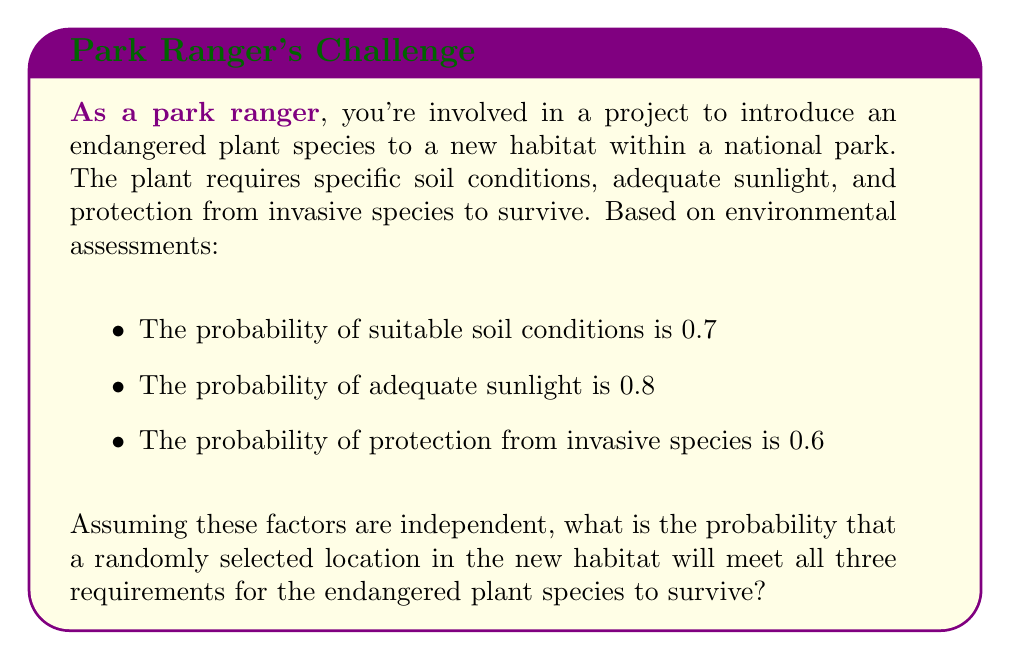Teach me how to tackle this problem. To solve this problem, we need to use the multiplication rule for independent events. Since all three conditions must be met for the plant to survive, we multiply the probabilities of each individual event:

1. Let A = event of suitable soil conditions (P(A) = 0.7)
2. Let B = event of adequate sunlight (P(B) = 0.8)
3. Let C = event of protection from invasive species (P(C) = 0.6)

The probability of all three events occurring simultaneously is:

$$P(A \cap B \cap C) = P(A) \times P(B) \times P(C)$$

Substituting the given probabilities:

$$P(A \cap B \cap C) = 0.7 \times 0.8 \times 0.6$$

Calculating:

$$P(A \cap B \cap C) = 0.336$$

Therefore, the probability that a randomly selected location in the new habitat will meet all three requirements for the endangered plant species to survive is 0.336 or 33.6%.
Answer: 0.336 